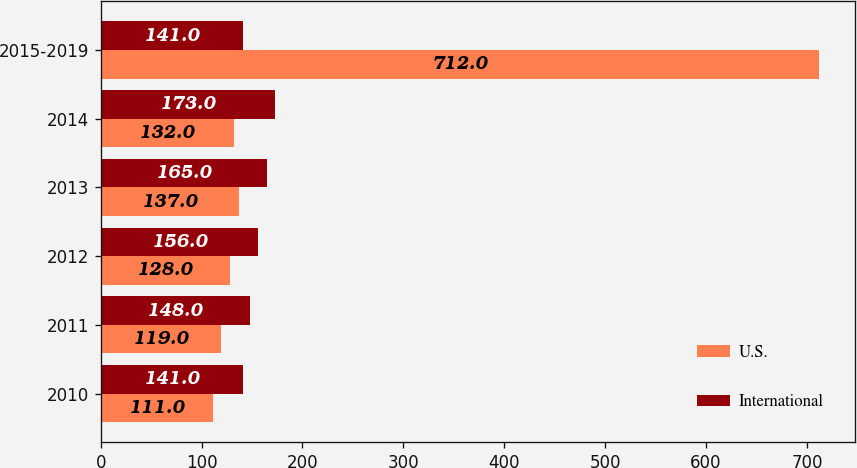<chart> <loc_0><loc_0><loc_500><loc_500><stacked_bar_chart><ecel><fcel>2010<fcel>2011<fcel>2012<fcel>2013<fcel>2014<fcel>2015-2019<nl><fcel>U.S.<fcel>111<fcel>119<fcel>128<fcel>137<fcel>132<fcel>712<nl><fcel>International<fcel>141<fcel>148<fcel>156<fcel>165<fcel>173<fcel>141<nl></chart> 